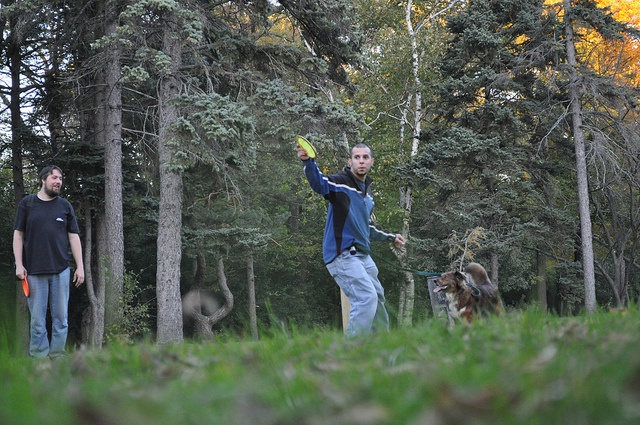Describe the objects in this image and their specific colors. I can see people in gray and black tones, people in gray, black, darkgray, and navy tones, dog in gray, black, and darkgray tones, frisbee in gray, khaki, and olive tones, and frisbee in gray, salmon, red, and brown tones in this image. 